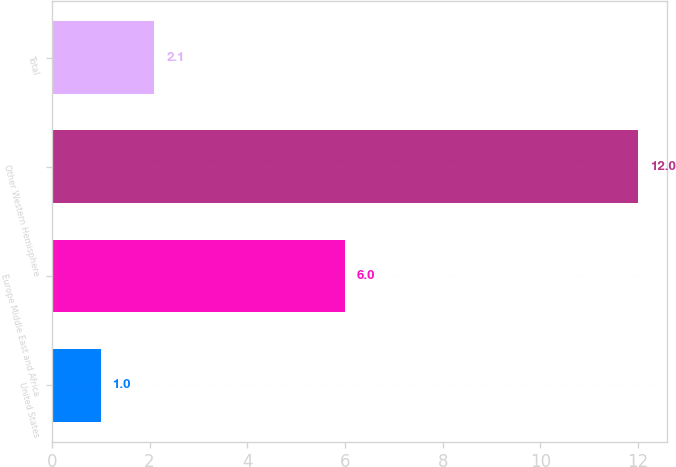Convert chart to OTSL. <chart><loc_0><loc_0><loc_500><loc_500><bar_chart><fcel>United States<fcel>Europe Middle East and Africa<fcel>Other Western Hemisphere<fcel>Total<nl><fcel>1<fcel>6<fcel>12<fcel>2.1<nl></chart> 